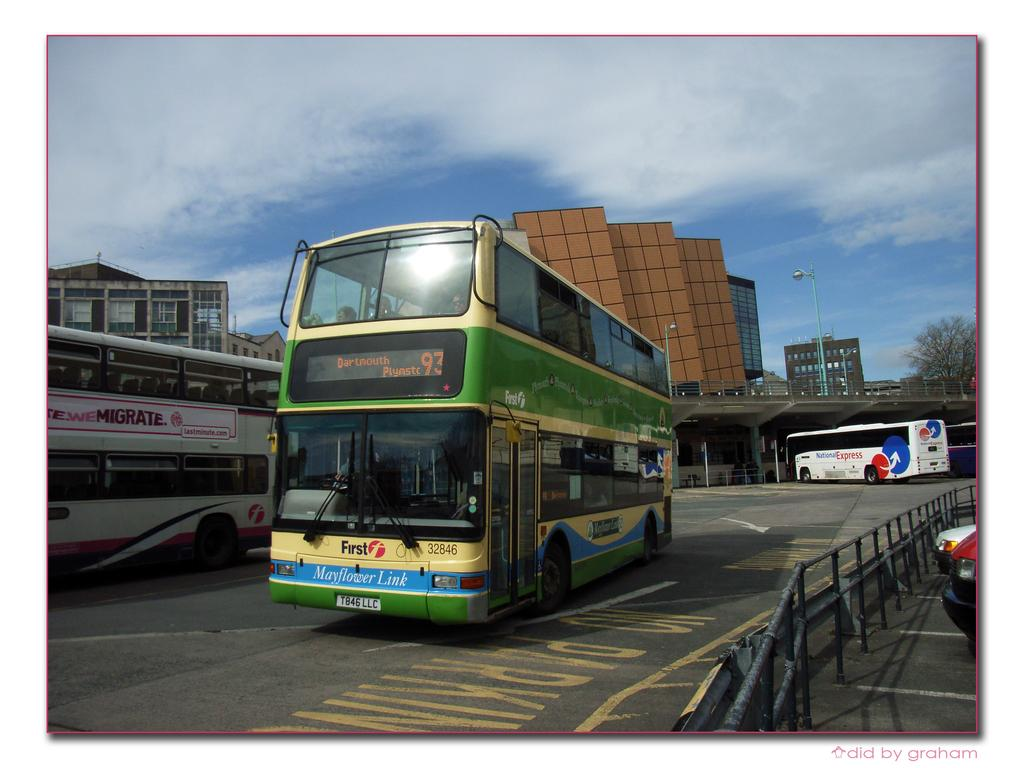What can be seen in the sky in the background of the image? There is a clear blue sky with clouds in the background of the image. What type of structures are visible in the distance? There are buildings visible in the background of the image. What mode of transportation can be seen on the road? Buses are present on the road in the image. What is located on the right side of the picture? There is a railing on the right side of the picture. Who is the owner of the cup seen in the image? There is no cup present in the image, so it is not possible to determine the owner. 